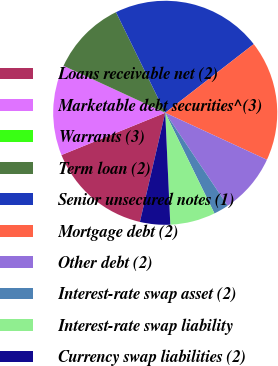<chart> <loc_0><loc_0><loc_500><loc_500><pie_chart><fcel>Loans receivable net (2)<fcel>Marketable debt securities^(3)<fcel>Warrants (3)<fcel>Term loan (2)<fcel>Senior unsecured notes (1)<fcel>Mortgage debt (2)<fcel>Other debt (2)<fcel>Interest-rate swap asset (2)<fcel>Interest-rate swap liability<fcel>Currency swap liabilities (2)<nl><fcel>15.22%<fcel>13.04%<fcel>0.0%<fcel>10.87%<fcel>21.74%<fcel>17.39%<fcel>8.7%<fcel>2.17%<fcel>6.52%<fcel>4.35%<nl></chart> 